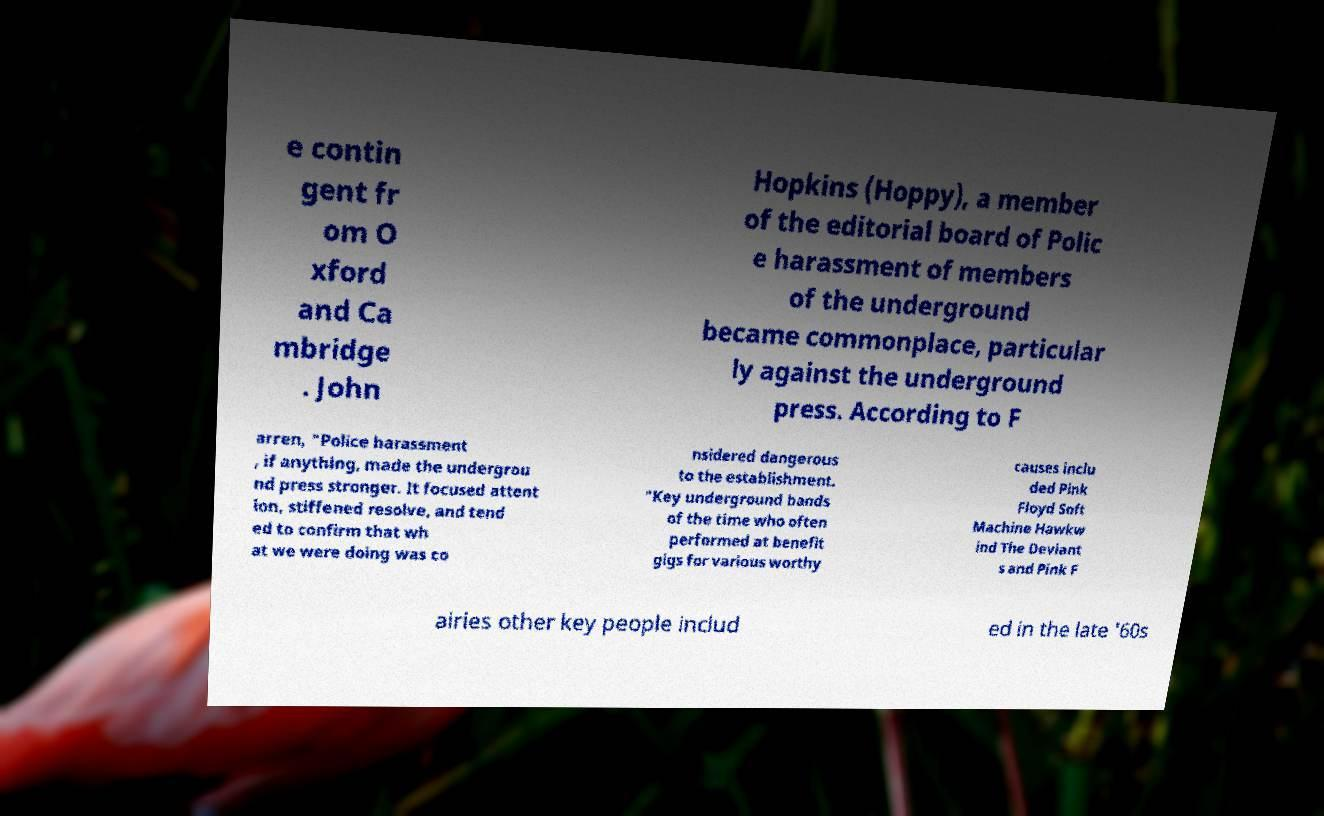I need the written content from this picture converted into text. Can you do that? e contin gent fr om O xford and Ca mbridge . John Hopkins (Hoppy), a member of the editorial board of Polic e harassment of members of the underground became commonplace, particular ly against the underground press. According to F arren, "Police harassment , if anything, made the undergrou nd press stronger. It focused attent ion, stiffened resolve, and tend ed to confirm that wh at we were doing was co nsidered dangerous to the establishment. "Key underground bands of the time who often performed at benefit gigs for various worthy causes inclu ded Pink Floyd Soft Machine Hawkw ind The Deviant s and Pink F airies other key people includ ed in the late '60s 